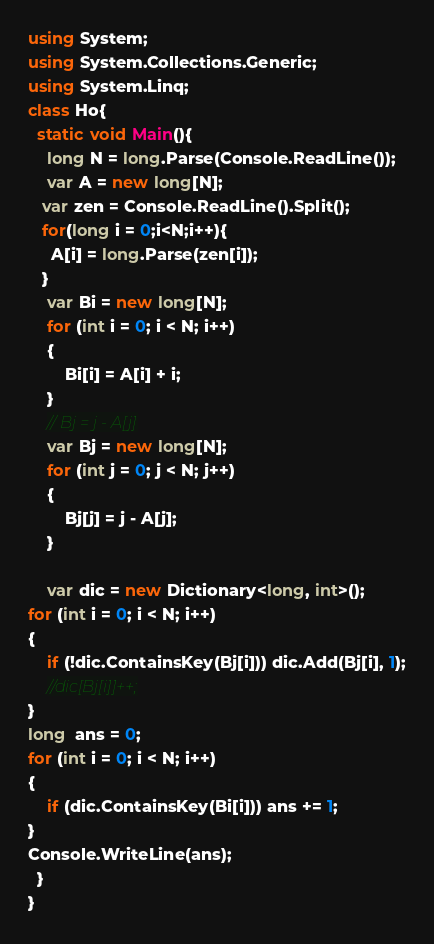Convert code to text. <code><loc_0><loc_0><loc_500><loc_500><_C#_>using System;
using System.Collections.Generic;
using System.Linq;
class Ho{
  static void Main(){
    long N = long.Parse(Console.ReadLine());
    var A = new long[N];
   var zen = Console.ReadLine().Split();
   for(long i = 0;i<N;i++){
     A[i] = long.Parse(zen[i]);
   }
    var Bi = new long[N];
    for (int i = 0; i < N; i++)
    {
        Bi[i] = A[i] + i;
    }
    // Bj = j - A[j]
    var Bj = new long[N];
    for (int j = 0; j < N; j++)
    {
        Bj[j] = j - A[j];
    }
    
    var dic = new Dictionary<long, int>();
for (int i = 0; i < N; i++)
{
    if (!dic.ContainsKey(Bj[i])) dic.Add(Bj[i], 1);
    //dic[Bj[i]]++;
}
long  ans = 0;
for (int i = 0; i < N; i++)
{
    if (dic.ContainsKey(Bi[i])) ans += 1;
}
Console.WriteLine(ans);
  }
}</code> 